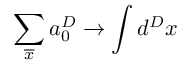<formula> <loc_0><loc_0><loc_500><loc_500>\sum _ { \overline { x } } a _ { 0 } ^ { D } \rightarrow \int d ^ { D } x</formula> 